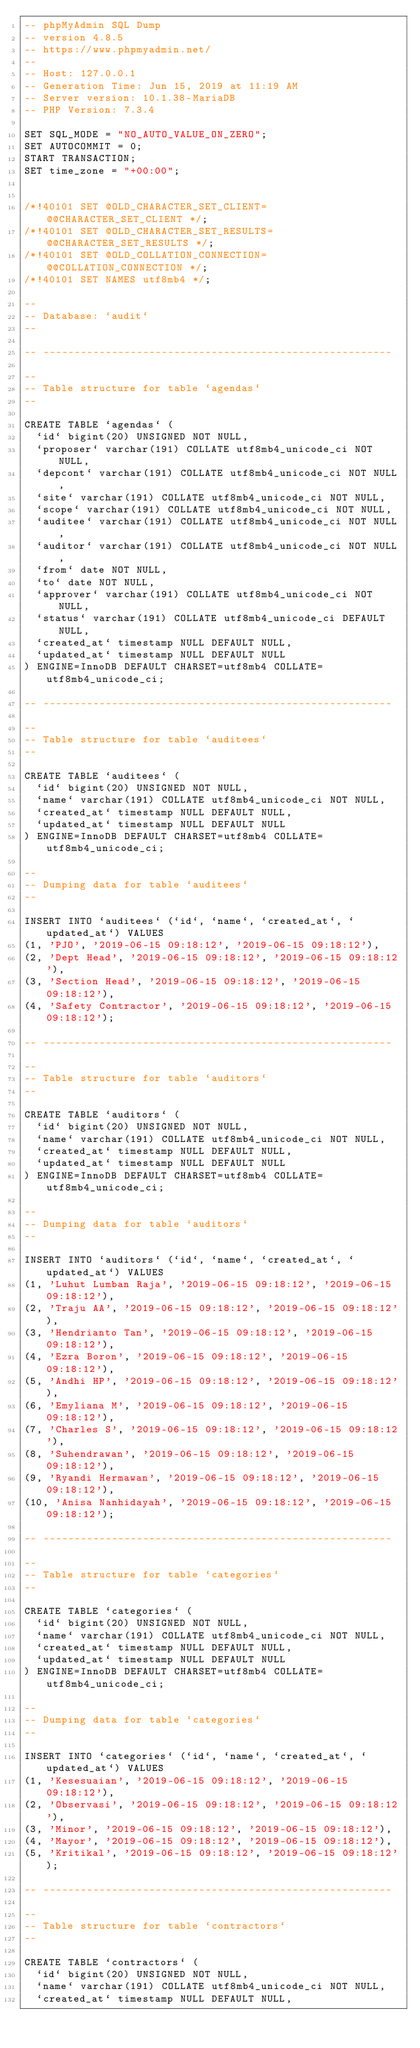Convert code to text. <code><loc_0><loc_0><loc_500><loc_500><_SQL_>-- phpMyAdmin SQL Dump
-- version 4.8.5
-- https://www.phpmyadmin.net/
--
-- Host: 127.0.0.1
-- Generation Time: Jun 15, 2019 at 11:19 AM
-- Server version: 10.1.38-MariaDB
-- PHP Version: 7.3.4

SET SQL_MODE = "NO_AUTO_VALUE_ON_ZERO";
SET AUTOCOMMIT = 0;
START TRANSACTION;
SET time_zone = "+00:00";


/*!40101 SET @OLD_CHARACTER_SET_CLIENT=@@CHARACTER_SET_CLIENT */;
/*!40101 SET @OLD_CHARACTER_SET_RESULTS=@@CHARACTER_SET_RESULTS */;
/*!40101 SET @OLD_COLLATION_CONNECTION=@@COLLATION_CONNECTION */;
/*!40101 SET NAMES utf8mb4 */;

--
-- Database: `audit`
--

-- --------------------------------------------------------

--
-- Table structure for table `agendas`
--

CREATE TABLE `agendas` (
  `id` bigint(20) UNSIGNED NOT NULL,
  `proposer` varchar(191) COLLATE utf8mb4_unicode_ci NOT NULL,
  `depcont` varchar(191) COLLATE utf8mb4_unicode_ci NOT NULL,
  `site` varchar(191) COLLATE utf8mb4_unicode_ci NOT NULL,
  `scope` varchar(191) COLLATE utf8mb4_unicode_ci NOT NULL,
  `auditee` varchar(191) COLLATE utf8mb4_unicode_ci NOT NULL,
  `auditor` varchar(191) COLLATE utf8mb4_unicode_ci NOT NULL,
  `from` date NOT NULL,
  `to` date NOT NULL,
  `approver` varchar(191) COLLATE utf8mb4_unicode_ci NOT NULL,
  `status` varchar(191) COLLATE utf8mb4_unicode_ci DEFAULT NULL,
  `created_at` timestamp NULL DEFAULT NULL,
  `updated_at` timestamp NULL DEFAULT NULL
) ENGINE=InnoDB DEFAULT CHARSET=utf8mb4 COLLATE=utf8mb4_unicode_ci;

-- --------------------------------------------------------

--
-- Table structure for table `auditees`
--

CREATE TABLE `auditees` (
  `id` bigint(20) UNSIGNED NOT NULL,
  `name` varchar(191) COLLATE utf8mb4_unicode_ci NOT NULL,
  `created_at` timestamp NULL DEFAULT NULL,
  `updated_at` timestamp NULL DEFAULT NULL
) ENGINE=InnoDB DEFAULT CHARSET=utf8mb4 COLLATE=utf8mb4_unicode_ci;

--
-- Dumping data for table `auditees`
--

INSERT INTO `auditees` (`id`, `name`, `created_at`, `updated_at`) VALUES
(1, 'PJO', '2019-06-15 09:18:12', '2019-06-15 09:18:12'),
(2, 'Dept Head', '2019-06-15 09:18:12', '2019-06-15 09:18:12'),
(3, 'Section Head', '2019-06-15 09:18:12', '2019-06-15 09:18:12'),
(4, 'Safety Contractor', '2019-06-15 09:18:12', '2019-06-15 09:18:12');

-- --------------------------------------------------------

--
-- Table structure for table `auditors`
--

CREATE TABLE `auditors` (
  `id` bigint(20) UNSIGNED NOT NULL,
  `name` varchar(191) COLLATE utf8mb4_unicode_ci NOT NULL,
  `created_at` timestamp NULL DEFAULT NULL,
  `updated_at` timestamp NULL DEFAULT NULL
) ENGINE=InnoDB DEFAULT CHARSET=utf8mb4 COLLATE=utf8mb4_unicode_ci;

--
-- Dumping data for table `auditors`
--

INSERT INTO `auditors` (`id`, `name`, `created_at`, `updated_at`) VALUES
(1, 'Luhut Lumban Raja', '2019-06-15 09:18:12', '2019-06-15 09:18:12'),
(2, 'Traju AA', '2019-06-15 09:18:12', '2019-06-15 09:18:12'),
(3, 'Hendrianto Tan', '2019-06-15 09:18:12', '2019-06-15 09:18:12'),
(4, 'Ezra Boron', '2019-06-15 09:18:12', '2019-06-15 09:18:12'),
(5, 'Andhi HP', '2019-06-15 09:18:12', '2019-06-15 09:18:12'),
(6, 'Emyliana M', '2019-06-15 09:18:12', '2019-06-15 09:18:12'),
(7, 'Charles S', '2019-06-15 09:18:12', '2019-06-15 09:18:12'),
(8, 'Suhendrawan', '2019-06-15 09:18:12', '2019-06-15 09:18:12'),
(9, 'Ryandi Hermawan', '2019-06-15 09:18:12', '2019-06-15 09:18:12'),
(10, 'Anisa Nanhidayah', '2019-06-15 09:18:12', '2019-06-15 09:18:12');

-- --------------------------------------------------------

--
-- Table structure for table `categories`
--

CREATE TABLE `categories` (
  `id` bigint(20) UNSIGNED NOT NULL,
  `name` varchar(191) COLLATE utf8mb4_unicode_ci NOT NULL,
  `created_at` timestamp NULL DEFAULT NULL,
  `updated_at` timestamp NULL DEFAULT NULL
) ENGINE=InnoDB DEFAULT CHARSET=utf8mb4 COLLATE=utf8mb4_unicode_ci;

--
-- Dumping data for table `categories`
--

INSERT INTO `categories` (`id`, `name`, `created_at`, `updated_at`) VALUES
(1, 'Kesesuaian', '2019-06-15 09:18:12', '2019-06-15 09:18:12'),
(2, 'Observasi', '2019-06-15 09:18:12', '2019-06-15 09:18:12'),
(3, 'Minor', '2019-06-15 09:18:12', '2019-06-15 09:18:12'),
(4, 'Mayor', '2019-06-15 09:18:12', '2019-06-15 09:18:12'),
(5, 'Kritikal', '2019-06-15 09:18:12', '2019-06-15 09:18:12');

-- --------------------------------------------------------

--
-- Table structure for table `contractors`
--

CREATE TABLE `contractors` (
  `id` bigint(20) UNSIGNED NOT NULL,
  `name` varchar(191) COLLATE utf8mb4_unicode_ci NOT NULL,
  `created_at` timestamp NULL DEFAULT NULL,</code> 